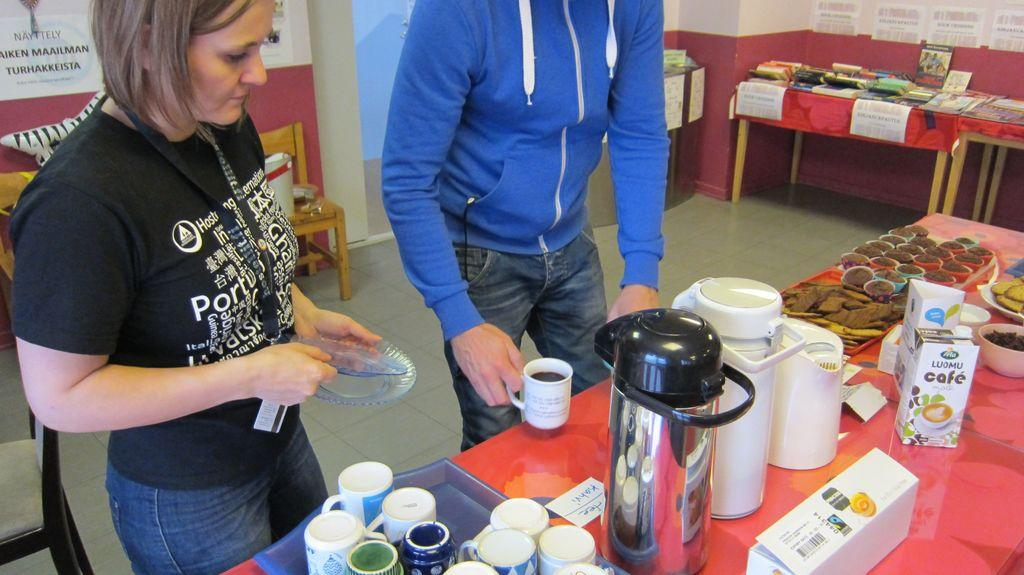<image>
Give a short and clear explanation of the subsequent image. Two people in front of a table with a container of Luomu Cafe on it. 